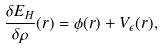Convert formula to latex. <formula><loc_0><loc_0><loc_500><loc_500>\frac { \delta E _ { H } } { \delta \rho } ( { r } ) = \phi ( { r } ) + V _ { \epsilon } ( { r } ) ,</formula> 